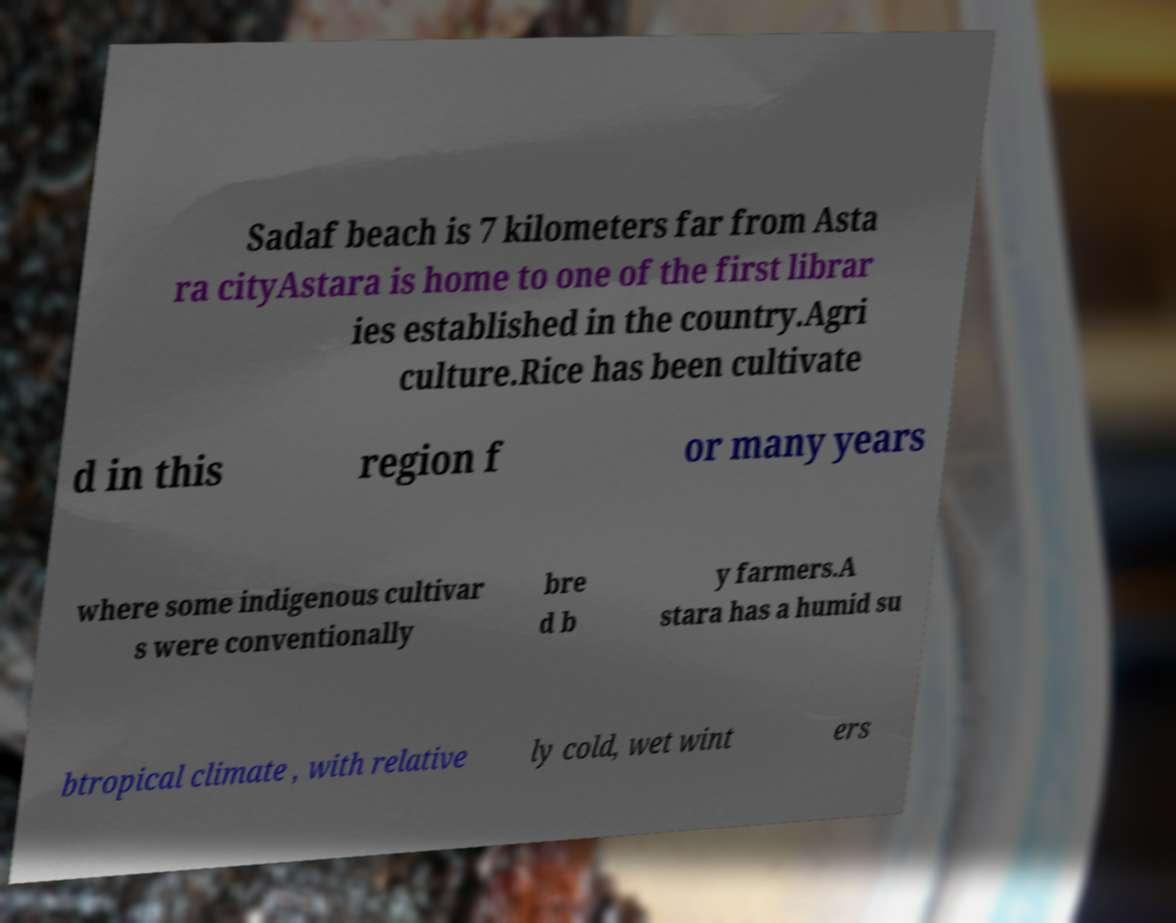Please identify and transcribe the text found in this image. Sadaf beach is 7 kilometers far from Asta ra cityAstara is home to one of the first librar ies established in the country.Agri culture.Rice has been cultivate d in this region f or many years where some indigenous cultivar s were conventionally bre d b y farmers.A stara has a humid su btropical climate , with relative ly cold, wet wint ers 